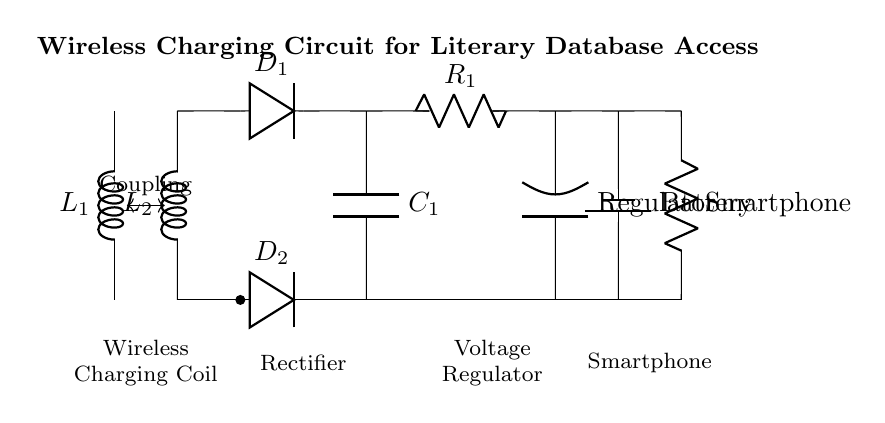What type of circuit is this? This is a wireless charging circuit, designed to transfer energy wirelessly to charge a smartphone, enabling access to online literary databases.
Answer: Wireless charging circuit Which component is used for rectification? The rectification in this circuit is performed by the diode labeled D1, converting AC into DC, necessary for battery charging.
Answer: Diode D1 What is the purpose of the capacitor in this circuit? The capacitor, labeled C1, smooths the rectified voltage, ensuring that fluctuations in voltage do not affect the performance of the smartphone load.
Answer: Smooths voltage How many coils are present in the circuit? There are two coils in the circuit diagram, labeled L1 and L2, which are responsible for the wireless energy transfer through magnetic coupling.
Answer: Two coils What role does the voltage regulator play? The voltage regulator, shown as a block labeled 'Regulator', stabilizes the output voltage to a specific level that is safe and suitable for charging the smartphone's battery.
Answer: Stabilizes voltage Which component represents the smartphone in the circuit? The smartphone is represented by the resistor labeled 'Smartphone', which acts as the load that consumes power supplied by the battery.
Answer: Resistor Smartphone 